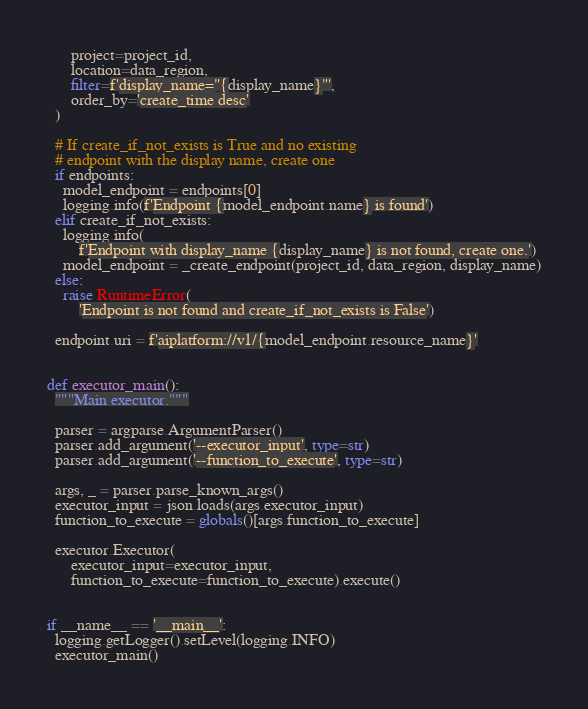Convert code to text. <code><loc_0><loc_0><loc_500><loc_500><_Python_>      project=project_id,
      location=data_region,
      filter=f'display_name="{display_name}"',
      order_by='create_time desc'
  )

  # If create_if_not_exists is True and no existing
  # endpoint with the display name, create one
  if endpoints:
    model_endpoint = endpoints[0]
    logging.info(f'Endpoint {model_endpoint.name} is found')
  elif create_if_not_exists:
    logging.info(
        f'Endpoint with display_name {display_name} is not found, create one.')
    model_endpoint = _create_endpoint(project_id, data_region, display_name)
  else:
    raise RuntimeError(
        'Endpoint is not found and create_if_not_exists is False')

  endpoint.uri = f'aiplatform://v1/{model_endpoint.resource_name}'


def executor_main():
  """Main executor."""

  parser = argparse.ArgumentParser()
  parser.add_argument('--executor_input', type=str)
  parser.add_argument('--function_to_execute', type=str)

  args, _ = parser.parse_known_args()
  executor_input = json.loads(args.executor_input)
  function_to_execute = globals()[args.function_to_execute]

  executor.Executor(
      executor_input=executor_input,
      function_to_execute=function_to_execute).execute()


if __name__ == '__main__':
  logging.getLogger().setLevel(logging.INFO)
  executor_main()
</code> 